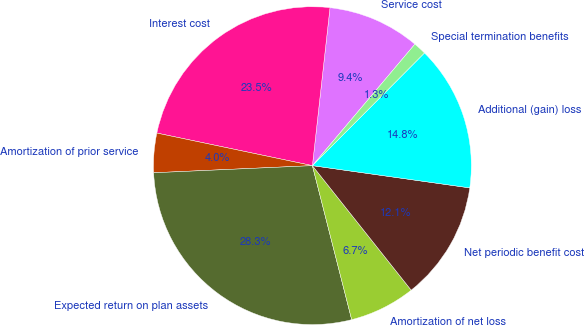Convert chart to OTSL. <chart><loc_0><loc_0><loc_500><loc_500><pie_chart><fcel>Service cost<fcel>Interest cost<fcel>Amortization of prior service<fcel>Expected return on plan assets<fcel>Amortization of net loss<fcel>Net periodic benefit cost<fcel>Additional (gain) loss<fcel>Special termination benefits<nl><fcel>9.39%<fcel>23.48%<fcel>4.0%<fcel>28.26%<fcel>6.7%<fcel>12.09%<fcel>14.78%<fcel>1.3%<nl></chart> 